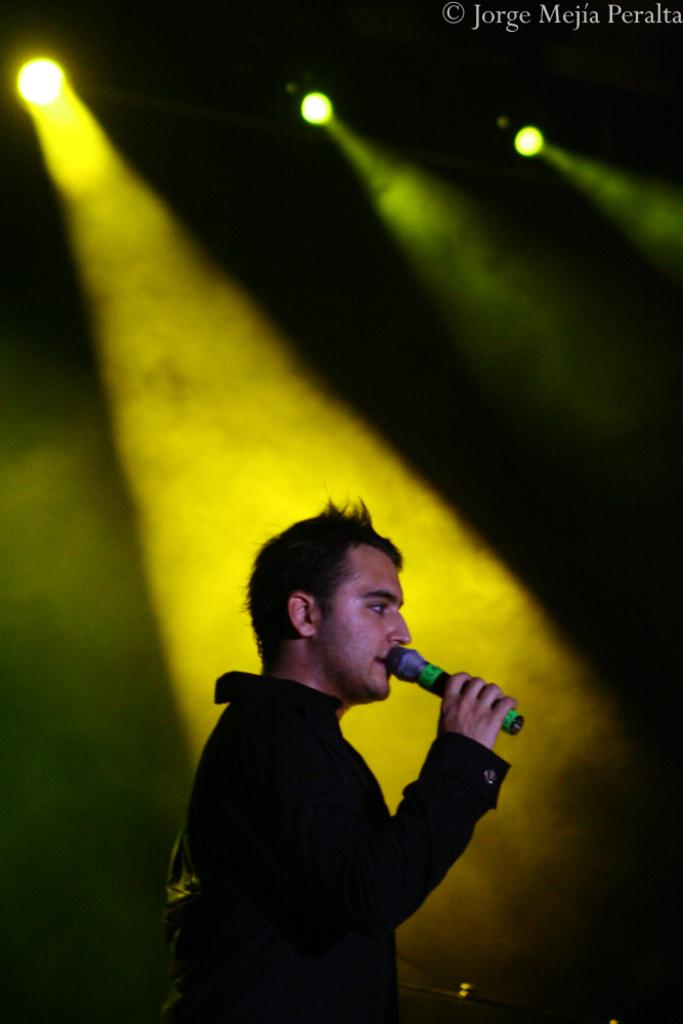What is the man in the image doing? The man is standing in the image and holding a mic in his hand. What can be seen behind the man? There are lights visible behind the man. Is there any text or label in the image? Yes, there is a name in the top right corner of the image. What direction is the station moving in the image? There is no station present in the image, so it is not possible to determine the direction of movement. 